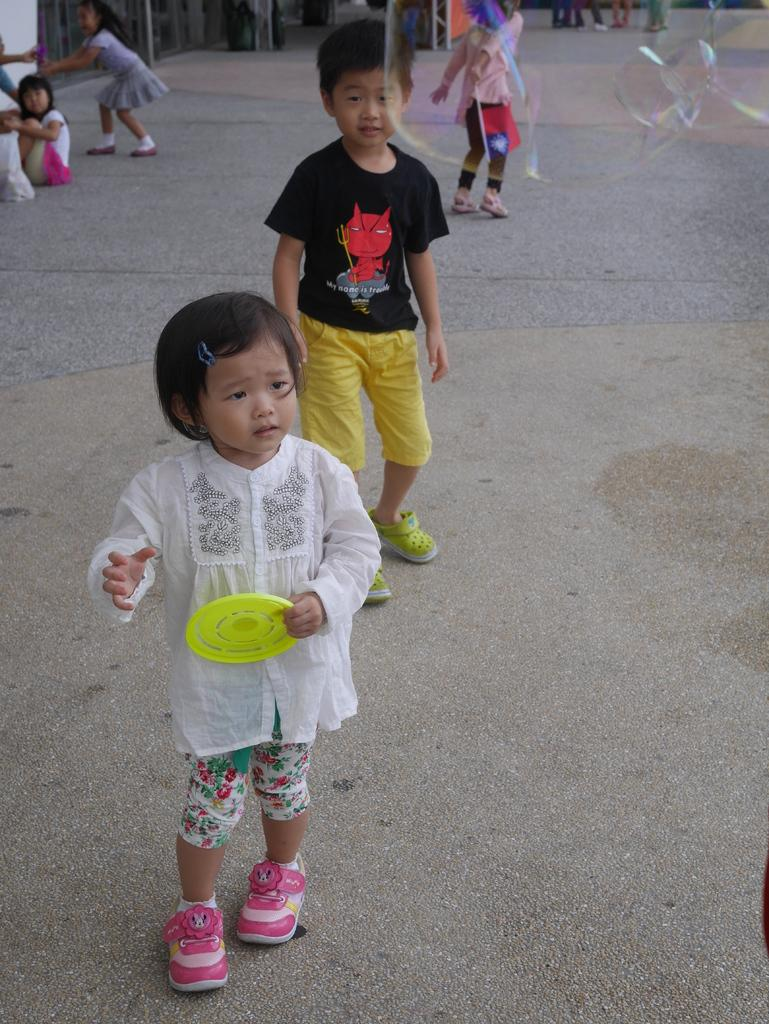How many children are in the image? There are children in the image, but the exact number is not specified. Can you describe the gender of the children in the image? There are both girls and boys in the image. What object is one of the children holding? One of the children is holding a Frisbee. What type of nail is being used to hold the tripod in the image? There is no tripod or nail present in the image; it features children and a Frisbee. 